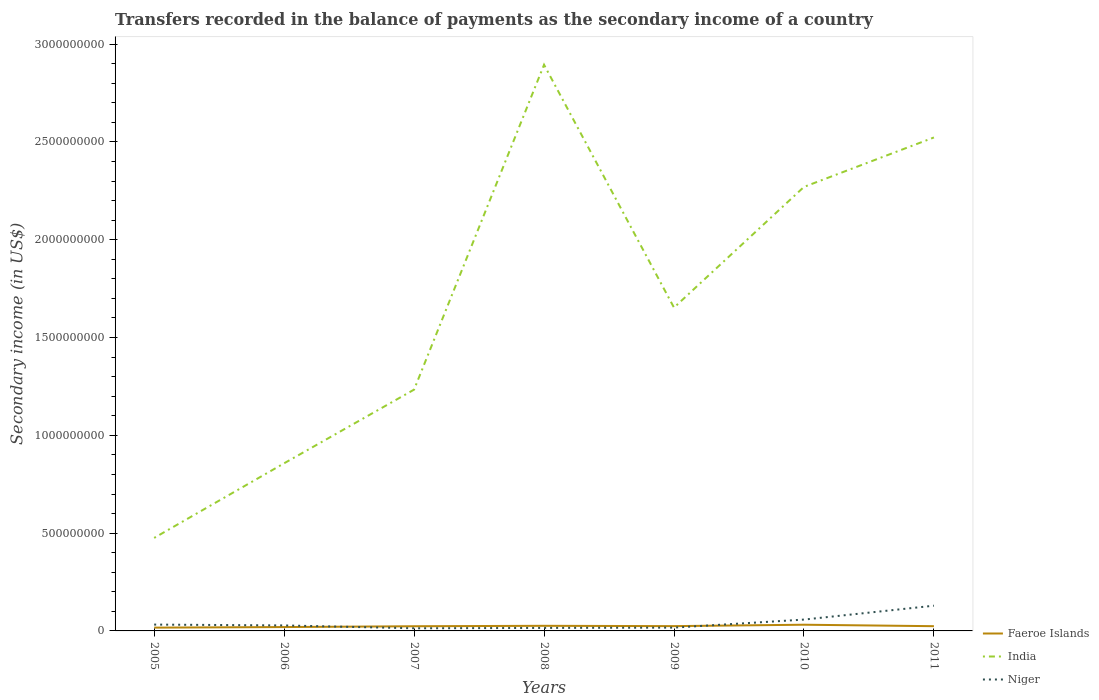Does the line corresponding to India intersect with the line corresponding to Niger?
Give a very brief answer. No. Across all years, what is the maximum secondary income of in Niger?
Keep it short and to the point. 1.35e+07. In which year was the secondary income of in India maximum?
Make the answer very short. 2005. What is the total secondary income of in Faeroe Islands in the graph?
Keep it short and to the point. -4.24e+06. What is the difference between the highest and the second highest secondary income of in Niger?
Make the answer very short. 1.16e+08. Is the secondary income of in Niger strictly greater than the secondary income of in Faeroe Islands over the years?
Offer a terse response. No. How many lines are there?
Provide a short and direct response. 3. Does the graph contain any zero values?
Ensure brevity in your answer.  No. Where does the legend appear in the graph?
Offer a terse response. Bottom right. How many legend labels are there?
Provide a short and direct response. 3. What is the title of the graph?
Offer a terse response. Transfers recorded in the balance of payments as the secondary income of a country. Does "Gabon" appear as one of the legend labels in the graph?
Keep it short and to the point. No. What is the label or title of the X-axis?
Ensure brevity in your answer.  Years. What is the label or title of the Y-axis?
Provide a short and direct response. Secondary income (in US$). What is the Secondary income (in US$) of Faeroe Islands in 2005?
Make the answer very short. 1.69e+07. What is the Secondary income (in US$) in India in 2005?
Your response must be concise. 4.76e+08. What is the Secondary income (in US$) of Niger in 2005?
Offer a very short reply. 3.24e+07. What is the Secondary income (in US$) in Faeroe Islands in 2006?
Make the answer very short. 1.97e+07. What is the Secondary income (in US$) of India in 2006?
Your answer should be very brief. 8.57e+08. What is the Secondary income (in US$) in Niger in 2006?
Offer a terse response. 2.80e+07. What is the Secondary income (in US$) in Faeroe Islands in 2007?
Provide a succinct answer. 2.40e+07. What is the Secondary income (in US$) of India in 2007?
Make the answer very short. 1.23e+09. What is the Secondary income (in US$) of Niger in 2007?
Provide a short and direct response. 1.35e+07. What is the Secondary income (in US$) of Faeroe Islands in 2008?
Make the answer very short. 2.61e+07. What is the Secondary income (in US$) of India in 2008?
Your answer should be very brief. 2.89e+09. What is the Secondary income (in US$) in Niger in 2008?
Your response must be concise. 1.53e+07. What is the Secondary income (in US$) in Faeroe Islands in 2009?
Provide a succinct answer. 2.45e+07. What is the Secondary income (in US$) of India in 2009?
Offer a very short reply. 1.65e+09. What is the Secondary income (in US$) in Niger in 2009?
Ensure brevity in your answer.  1.69e+07. What is the Secondary income (in US$) of Faeroe Islands in 2010?
Keep it short and to the point. 3.17e+07. What is the Secondary income (in US$) in India in 2010?
Offer a terse response. 2.27e+09. What is the Secondary income (in US$) in Niger in 2010?
Provide a succinct answer. 5.80e+07. What is the Secondary income (in US$) of Faeroe Islands in 2011?
Make the answer very short. 2.42e+07. What is the Secondary income (in US$) of India in 2011?
Keep it short and to the point. 2.52e+09. What is the Secondary income (in US$) of Niger in 2011?
Provide a short and direct response. 1.29e+08. Across all years, what is the maximum Secondary income (in US$) in Faeroe Islands?
Your answer should be very brief. 3.17e+07. Across all years, what is the maximum Secondary income (in US$) of India?
Ensure brevity in your answer.  2.89e+09. Across all years, what is the maximum Secondary income (in US$) in Niger?
Your response must be concise. 1.29e+08. Across all years, what is the minimum Secondary income (in US$) of Faeroe Islands?
Give a very brief answer. 1.69e+07. Across all years, what is the minimum Secondary income (in US$) of India?
Provide a succinct answer. 4.76e+08. Across all years, what is the minimum Secondary income (in US$) of Niger?
Give a very brief answer. 1.35e+07. What is the total Secondary income (in US$) in Faeroe Islands in the graph?
Your answer should be compact. 1.67e+08. What is the total Secondary income (in US$) in India in the graph?
Give a very brief answer. 1.19e+1. What is the total Secondary income (in US$) of Niger in the graph?
Your response must be concise. 2.93e+08. What is the difference between the Secondary income (in US$) in Faeroe Islands in 2005 and that in 2006?
Provide a short and direct response. -2.86e+06. What is the difference between the Secondary income (in US$) in India in 2005 and that in 2006?
Ensure brevity in your answer.  -3.82e+08. What is the difference between the Secondary income (in US$) in Niger in 2005 and that in 2006?
Provide a succinct answer. 4.39e+06. What is the difference between the Secondary income (in US$) of Faeroe Islands in 2005 and that in 2007?
Your response must be concise. -7.10e+06. What is the difference between the Secondary income (in US$) of India in 2005 and that in 2007?
Keep it short and to the point. -7.58e+08. What is the difference between the Secondary income (in US$) of Niger in 2005 and that in 2007?
Provide a succinct answer. 1.89e+07. What is the difference between the Secondary income (in US$) in Faeroe Islands in 2005 and that in 2008?
Your response must be concise. -9.24e+06. What is the difference between the Secondary income (in US$) of India in 2005 and that in 2008?
Make the answer very short. -2.42e+09. What is the difference between the Secondary income (in US$) in Niger in 2005 and that in 2008?
Give a very brief answer. 1.71e+07. What is the difference between the Secondary income (in US$) in Faeroe Islands in 2005 and that in 2009?
Make the answer very short. -7.68e+06. What is the difference between the Secondary income (in US$) of India in 2005 and that in 2009?
Your answer should be very brief. -1.18e+09. What is the difference between the Secondary income (in US$) in Niger in 2005 and that in 2009?
Give a very brief answer. 1.56e+07. What is the difference between the Secondary income (in US$) of Faeroe Islands in 2005 and that in 2010?
Provide a succinct answer. -1.49e+07. What is the difference between the Secondary income (in US$) of India in 2005 and that in 2010?
Ensure brevity in your answer.  -1.79e+09. What is the difference between the Secondary income (in US$) in Niger in 2005 and that in 2010?
Offer a terse response. -2.56e+07. What is the difference between the Secondary income (in US$) of Faeroe Islands in 2005 and that in 2011?
Provide a succinct answer. -7.34e+06. What is the difference between the Secondary income (in US$) of India in 2005 and that in 2011?
Provide a succinct answer. -2.05e+09. What is the difference between the Secondary income (in US$) of Niger in 2005 and that in 2011?
Provide a succinct answer. -9.66e+07. What is the difference between the Secondary income (in US$) of Faeroe Islands in 2006 and that in 2007?
Give a very brief answer. -4.24e+06. What is the difference between the Secondary income (in US$) in India in 2006 and that in 2007?
Provide a succinct answer. -3.77e+08. What is the difference between the Secondary income (in US$) of Niger in 2006 and that in 2007?
Make the answer very short. 1.46e+07. What is the difference between the Secondary income (in US$) of Faeroe Islands in 2006 and that in 2008?
Your response must be concise. -6.37e+06. What is the difference between the Secondary income (in US$) in India in 2006 and that in 2008?
Ensure brevity in your answer.  -2.04e+09. What is the difference between the Secondary income (in US$) of Niger in 2006 and that in 2008?
Provide a succinct answer. 1.27e+07. What is the difference between the Secondary income (in US$) in Faeroe Islands in 2006 and that in 2009?
Provide a succinct answer. -4.82e+06. What is the difference between the Secondary income (in US$) in India in 2006 and that in 2009?
Your answer should be compact. -7.96e+08. What is the difference between the Secondary income (in US$) in Niger in 2006 and that in 2009?
Provide a short and direct response. 1.12e+07. What is the difference between the Secondary income (in US$) in Faeroe Islands in 2006 and that in 2010?
Your answer should be compact. -1.20e+07. What is the difference between the Secondary income (in US$) of India in 2006 and that in 2010?
Your response must be concise. -1.41e+09. What is the difference between the Secondary income (in US$) of Niger in 2006 and that in 2010?
Ensure brevity in your answer.  -3.00e+07. What is the difference between the Secondary income (in US$) in Faeroe Islands in 2006 and that in 2011?
Offer a very short reply. -4.48e+06. What is the difference between the Secondary income (in US$) in India in 2006 and that in 2011?
Make the answer very short. -1.67e+09. What is the difference between the Secondary income (in US$) of Niger in 2006 and that in 2011?
Ensure brevity in your answer.  -1.01e+08. What is the difference between the Secondary income (in US$) of Faeroe Islands in 2007 and that in 2008?
Offer a very short reply. -2.14e+06. What is the difference between the Secondary income (in US$) of India in 2007 and that in 2008?
Make the answer very short. -1.66e+09. What is the difference between the Secondary income (in US$) of Niger in 2007 and that in 2008?
Provide a succinct answer. -1.83e+06. What is the difference between the Secondary income (in US$) of Faeroe Islands in 2007 and that in 2009?
Make the answer very short. -5.79e+05. What is the difference between the Secondary income (in US$) of India in 2007 and that in 2009?
Make the answer very short. -4.19e+08. What is the difference between the Secondary income (in US$) of Niger in 2007 and that in 2009?
Keep it short and to the point. -3.37e+06. What is the difference between the Secondary income (in US$) of Faeroe Islands in 2007 and that in 2010?
Your response must be concise. -7.79e+06. What is the difference between the Secondary income (in US$) of India in 2007 and that in 2010?
Your answer should be very brief. -1.04e+09. What is the difference between the Secondary income (in US$) in Niger in 2007 and that in 2010?
Your response must be concise. -4.45e+07. What is the difference between the Secondary income (in US$) of Faeroe Islands in 2007 and that in 2011?
Ensure brevity in your answer.  -2.42e+05. What is the difference between the Secondary income (in US$) of India in 2007 and that in 2011?
Give a very brief answer. -1.29e+09. What is the difference between the Secondary income (in US$) in Niger in 2007 and that in 2011?
Keep it short and to the point. -1.16e+08. What is the difference between the Secondary income (in US$) in Faeroe Islands in 2008 and that in 2009?
Your answer should be compact. 1.56e+06. What is the difference between the Secondary income (in US$) of India in 2008 and that in 2009?
Provide a succinct answer. 1.24e+09. What is the difference between the Secondary income (in US$) in Niger in 2008 and that in 2009?
Provide a succinct answer. -1.55e+06. What is the difference between the Secondary income (in US$) of Faeroe Islands in 2008 and that in 2010?
Your answer should be very brief. -5.65e+06. What is the difference between the Secondary income (in US$) in India in 2008 and that in 2010?
Provide a succinct answer. 6.25e+08. What is the difference between the Secondary income (in US$) of Niger in 2008 and that in 2010?
Provide a succinct answer. -4.27e+07. What is the difference between the Secondary income (in US$) of Faeroe Islands in 2008 and that in 2011?
Your response must be concise. 1.90e+06. What is the difference between the Secondary income (in US$) of India in 2008 and that in 2011?
Provide a short and direct response. 3.72e+08. What is the difference between the Secondary income (in US$) in Niger in 2008 and that in 2011?
Provide a short and direct response. -1.14e+08. What is the difference between the Secondary income (in US$) of Faeroe Islands in 2009 and that in 2010?
Offer a terse response. -7.21e+06. What is the difference between the Secondary income (in US$) of India in 2009 and that in 2010?
Offer a terse response. -6.17e+08. What is the difference between the Secondary income (in US$) of Niger in 2009 and that in 2010?
Provide a short and direct response. -4.12e+07. What is the difference between the Secondary income (in US$) in Faeroe Islands in 2009 and that in 2011?
Give a very brief answer. 3.37e+05. What is the difference between the Secondary income (in US$) in India in 2009 and that in 2011?
Provide a short and direct response. -8.70e+08. What is the difference between the Secondary income (in US$) in Niger in 2009 and that in 2011?
Your answer should be compact. -1.12e+08. What is the difference between the Secondary income (in US$) in Faeroe Islands in 2010 and that in 2011?
Offer a very short reply. 7.55e+06. What is the difference between the Secondary income (in US$) of India in 2010 and that in 2011?
Your answer should be compact. -2.53e+08. What is the difference between the Secondary income (in US$) in Niger in 2010 and that in 2011?
Your response must be concise. -7.10e+07. What is the difference between the Secondary income (in US$) in Faeroe Islands in 2005 and the Secondary income (in US$) in India in 2006?
Make the answer very short. -8.40e+08. What is the difference between the Secondary income (in US$) in Faeroe Islands in 2005 and the Secondary income (in US$) in Niger in 2006?
Provide a short and direct response. -1.12e+07. What is the difference between the Secondary income (in US$) of India in 2005 and the Secondary income (in US$) of Niger in 2006?
Your answer should be very brief. 4.47e+08. What is the difference between the Secondary income (in US$) of Faeroe Islands in 2005 and the Secondary income (in US$) of India in 2007?
Keep it short and to the point. -1.22e+09. What is the difference between the Secondary income (in US$) of Faeroe Islands in 2005 and the Secondary income (in US$) of Niger in 2007?
Offer a terse response. 3.38e+06. What is the difference between the Secondary income (in US$) of India in 2005 and the Secondary income (in US$) of Niger in 2007?
Your response must be concise. 4.62e+08. What is the difference between the Secondary income (in US$) in Faeroe Islands in 2005 and the Secondary income (in US$) in India in 2008?
Offer a terse response. -2.88e+09. What is the difference between the Secondary income (in US$) of Faeroe Islands in 2005 and the Secondary income (in US$) of Niger in 2008?
Your answer should be very brief. 1.55e+06. What is the difference between the Secondary income (in US$) in India in 2005 and the Secondary income (in US$) in Niger in 2008?
Give a very brief answer. 4.60e+08. What is the difference between the Secondary income (in US$) in Faeroe Islands in 2005 and the Secondary income (in US$) in India in 2009?
Offer a very short reply. -1.64e+09. What is the difference between the Secondary income (in US$) of Faeroe Islands in 2005 and the Secondary income (in US$) of Niger in 2009?
Offer a very short reply. 5214.1. What is the difference between the Secondary income (in US$) in India in 2005 and the Secondary income (in US$) in Niger in 2009?
Your answer should be compact. 4.59e+08. What is the difference between the Secondary income (in US$) in Faeroe Islands in 2005 and the Secondary income (in US$) in India in 2010?
Your answer should be compact. -2.25e+09. What is the difference between the Secondary income (in US$) in Faeroe Islands in 2005 and the Secondary income (in US$) in Niger in 2010?
Keep it short and to the point. -4.11e+07. What is the difference between the Secondary income (in US$) in India in 2005 and the Secondary income (in US$) in Niger in 2010?
Provide a succinct answer. 4.18e+08. What is the difference between the Secondary income (in US$) of Faeroe Islands in 2005 and the Secondary income (in US$) of India in 2011?
Ensure brevity in your answer.  -2.51e+09. What is the difference between the Secondary income (in US$) in Faeroe Islands in 2005 and the Secondary income (in US$) in Niger in 2011?
Provide a short and direct response. -1.12e+08. What is the difference between the Secondary income (in US$) of India in 2005 and the Secondary income (in US$) of Niger in 2011?
Offer a terse response. 3.47e+08. What is the difference between the Secondary income (in US$) in Faeroe Islands in 2006 and the Secondary income (in US$) in India in 2007?
Make the answer very short. -1.21e+09. What is the difference between the Secondary income (in US$) of Faeroe Islands in 2006 and the Secondary income (in US$) of Niger in 2007?
Offer a terse response. 6.24e+06. What is the difference between the Secondary income (in US$) in India in 2006 and the Secondary income (in US$) in Niger in 2007?
Offer a very short reply. 8.44e+08. What is the difference between the Secondary income (in US$) of Faeroe Islands in 2006 and the Secondary income (in US$) of India in 2008?
Your response must be concise. -2.87e+09. What is the difference between the Secondary income (in US$) of Faeroe Islands in 2006 and the Secondary income (in US$) of Niger in 2008?
Your answer should be compact. 4.41e+06. What is the difference between the Secondary income (in US$) of India in 2006 and the Secondary income (in US$) of Niger in 2008?
Your answer should be very brief. 8.42e+08. What is the difference between the Secondary income (in US$) of Faeroe Islands in 2006 and the Secondary income (in US$) of India in 2009?
Offer a very short reply. -1.63e+09. What is the difference between the Secondary income (in US$) of Faeroe Islands in 2006 and the Secondary income (in US$) of Niger in 2009?
Offer a terse response. 2.87e+06. What is the difference between the Secondary income (in US$) of India in 2006 and the Secondary income (in US$) of Niger in 2009?
Provide a succinct answer. 8.40e+08. What is the difference between the Secondary income (in US$) of Faeroe Islands in 2006 and the Secondary income (in US$) of India in 2010?
Your answer should be compact. -2.25e+09. What is the difference between the Secondary income (in US$) of Faeroe Islands in 2006 and the Secondary income (in US$) of Niger in 2010?
Ensure brevity in your answer.  -3.83e+07. What is the difference between the Secondary income (in US$) of India in 2006 and the Secondary income (in US$) of Niger in 2010?
Provide a short and direct response. 7.99e+08. What is the difference between the Secondary income (in US$) of Faeroe Islands in 2006 and the Secondary income (in US$) of India in 2011?
Offer a terse response. -2.50e+09. What is the difference between the Secondary income (in US$) of Faeroe Islands in 2006 and the Secondary income (in US$) of Niger in 2011?
Provide a short and direct response. -1.09e+08. What is the difference between the Secondary income (in US$) in India in 2006 and the Secondary income (in US$) in Niger in 2011?
Provide a succinct answer. 7.28e+08. What is the difference between the Secondary income (in US$) in Faeroe Islands in 2007 and the Secondary income (in US$) in India in 2008?
Your answer should be very brief. -2.87e+09. What is the difference between the Secondary income (in US$) in Faeroe Islands in 2007 and the Secondary income (in US$) in Niger in 2008?
Provide a short and direct response. 8.65e+06. What is the difference between the Secondary income (in US$) in India in 2007 and the Secondary income (in US$) in Niger in 2008?
Provide a short and direct response. 1.22e+09. What is the difference between the Secondary income (in US$) in Faeroe Islands in 2007 and the Secondary income (in US$) in India in 2009?
Give a very brief answer. -1.63e+09. What is the difference between the Secondary income (in US$) in Faeroe Islands in 2007 and the Secondary income (in US$) in Niger in 2009?
Offer a terse response. 7.10e+06. What is the difference between the Secondary income (in US$) of India in 2007 and the Secondary income (in US$) of Niger in 2009?
Provide a short and direct response. 1.22e+09. What is the difference between the Secondary income (in US$) in Faeroe Islands in 2007 and the Secondary income (in US$) in India in 2010?
Offer a terse response. -2.25e+09. What is the difference between the Secondary income (in US$) of Faeroe Islands in 2007 and the Secondary income (in US$) of Niger in 2010?
Offer a terse response. -3.40e+07. What is the difference between the Secondary income (in US$) in India in 2007 and the Secondary income (in US$) in Niger in 2010?
Give a very brief answer. 1.18e+09. What is the difference between the Secondary income (in US$) of Faeroe Islands in 2007 and the Secondary income (in US$) of India in 2011?
Provide a succinct answer. -2.50e+09. What is the difference between the Secondary income (in US$) of Faeroe Islands in 2007 and the Secondary income (in US$) of Niger in 2011?
Give a very brief answer. -1.05e+08. What is the difference between the Secondary income (in US$) in India in 2007 and the Secondary income (in US$) in Niger in 2011?
Your response must be concise. 1.10e+09. What is the difference between the Secondary income (in US$) in Faeroe Islands in 2008 and the Secondary income (in US$) in India in 2009?
Keep it short and to the point. -1.63e+09. What is the difference between the Secondary income (in US$) in Faeroe Islands in 2008 and the Secondary income (in US$) in Niger in 2009?
Provide a short and direct response. 9.24e+06. What is the difference between the Secondary income (in US$) in India in 2008 and the Secondary income (in US$) in Niger in 2009?
Offer a terse response. 2.88e+09. What is the difference between the Secondary income (in US$) in Faeroe Islands in 2008 and the Secondary income (in US$) in India in 2010?
Offer a very short reply. -2.24e+09. What is the difference between the Secondary income (in US$) of Faeroe Islands in 2008 and the Secondary income (in US$) of Niger in 2010?
Make the answer very short. -3.19e+07. What is the difference between the Secondary income (in US$) in India in 2008 and the Secondary income (in US$) in Niger in 2010?
Provide a short and direct response. 2.84e+09. What is the difference between the Secondary income (in US$) in Faeroe Islands in 2008 and the Secondary income (in US$) in India in 2011?
Offer a terse response. -2.50e+09. What is the difference between the Secondary income (in US$) of Faeroe Islands in 2008 and the Secondary income (in US$) of Niger in 2011?
Make the answer very short. -1.03e+08. What is the difference between the Secondary income (in US$) of India in 2008 and the Secondary income (in US$) of Niger in 2011?
Make the answer very short. 2.77e+09. What is the difference between the Secondary income (in US$) of Faeroe Islands in 2009 and the Secondary income (in US$) of India in 2010?
Keep it short and to the point. -2.25e+09. What is the difference between the Secondary income (in US$) of Faeroe Islands in 2009 and the Secondary income (in US$) of Niger in 2010?
Provide a succinct answer. -3.35e+07. What is the difference between the Secondary income (in US$) of India in 2009 and the Secondary income (in US$) of Niger in 2010?
Your response must be concise. 1.59e+09. What is the difference between the Secondary income (in US$) in Faeroe Islands in 2009 and the Secondary income (in US$) in India in 2011?
Keep it short and to the point. -2.50e+09. What is the difference between the Secondary income (in US$) of Faeroe Islands in 2009 and the Secondary income (in US$) of Niger in 2011?
Your response must be concise. -1.04e+08. What is the difference between the Secondary income (in US$) in India in 2009 and the Secondary income (in US$) in Niger in 2011?
Provide a short and direct response. 1.52e+09. What is the difference between the Secondary income (in US$) in Faeroe Islands in 2010 and the Secondary income (in US$) in India in 2011?
Your answer should be compact. -2.49e+09. What is the difference between the Secondary income (in US$) of Faeroe Islands in 2010 and the Secondary income (in US$) of Niger in 2011?
Offer a very short reply. -9.72e+07. What is the difference between the Secondary income (in US$) in India in 2010 and the Secondary income (in US$) in Niger in 2011?
Keep it short and to the point. 2.14e+09. What is the average Secondary income (in US$) of Faeroe Islands per year?
Your response must be concise. 2.39e+07. What is the average Secondary income (in US$) in India per year?
Provide a short and direct response. 1.70e+09. What is the average Secondary income (in US$) of Niger per year?
Give a very brief answer. 4.19e+07. In the year 2005, what is the difference between the Secondary income (in US$) of Faeroe Islands and Secondary income (in US$) of India?
Offer a terse response. -4.59e+08. In the year 2005, what is the difference between the Secondary income (in US$) in Faeroe Islands and Secondary income (in US$) in Niger?
Make the answer very short. -1.56e+07. In the year 2005, what is the difference between the Secondary income (in US$) of India and Secondary income (in US$) of Niger?
Offer a terse response. 4.43e+08. In the year 2006, what is the difference between the Secondary income (in US$) in Faeroe Islands and Secondary income (in US$) in India?
Offer a very short reply. -8.37e+08. In the year 2006, what is the difference between the Secondary income (in US$) in Faeroe Islands and Secondary income (in US$) in Niger?
Offer a terse response. -8.31e+06. In the year 2006, what is the difference between the Secondary income (in US$) of India and Secondary income (in US$) of Niger?
Offer a very short reply. 8.29e+08. In the year 2007, what is the difference between the Secondary income (in US$) of Faeroe Islands and Secondary income (in US$) of India?
Give a very brief answer. -1.21e+09. In the year 2007, what is the difference between the Secondary income (in US$) in Faeroe Islands and Secondary income (in US$) in Niger?
Provide a succinct answer. 1.05e+07. In the year 2007, what is the difference between the Secondary income (in US$) in India and Secondary income (in US$) in Niger?
Offer a very short reply. 1.22e+09. In the year 2008, what is the difference between the Secondary income (in US$) in Faeroe Islands and Secondary income (in US$) in India?
Keep it short and to the point. -2.87e+09. In the year 2008, what is the difference between the Secondary income (in US$) of Faeroe Islands and Secondary income (in US$) of Niger?
Offer a terse response. 1.08e+07. In the year 2008, what is the difference between the Secondary income (in US$) in India and Secondary income (in US$) in Niger?
Your answer should be very brief. 2.88e+09. In the year 2009, what is the difference between the Secondary income (in US$) in Faeroe Islands and Secondary income (in US$) in India?
Keep it short and to the point. -1.63e+09. In the year 2009, what is the difference between the Secondary income (in US$) of Faeroe Islands and Secondary income (in US$) of Niger?
Your answer should be compact. 7.68e+06. In the year 2009, what is the difference between the Secondary income (in US$) in India and Secondary income (in US$) in Niger?
Offer a very short reply. 1.64e+09. In the year 2010, what is the difference between the Secondary income (in US$) in Faeroe Islands and Secondary income (in US$) in India?
Provide a short and direct response. -2.24e+09. In the year 2010, what is the difference between the Secondary income (in US$) in Faeroe Islands and Secondary income (in US$) in Niger?
Your answer should be very brief. -2.63e+07. In the year 2010, what is the difference between the Secondary income (in US$) of India and Secondary income (in US$) of Niger?
Provide a short and direct response. 2.21e+09. In the year 2011, what is the difference between the Secondary income (in US$) in Faeroe Islands and Secondary income (in US$) in India?
Provide a short and direct response. -2.50e+09. In the year 2011, what is the difference between the Secondary income (in US$) of Faeroe Islands and Secondary income (in US$) of Niger?
Provide a short and direct response. -1.05e+08. In the year 2011, what is the difference between the Secondary income (in US$) of India and Secondary income (in US$) of Niger?
Your answer should be very brief. 2.39e+09. What is the ratio of the Secondary income (in US$) in Faeroe Islands in 2005 to that in 2006?
Your answer should be compact. 0.85. What is the ratio of the Secondary income (in US$) of India in 2005 to that in 2006?
Offer a terse response. 0.55. What is the ratio of the Secondary income (in US$) of Niger in 2005 to that in 2006?
Offer a terse response. 1.16. What is the ratio of the Secondary income (in US$) in Faeroe Islands in 2005 to that in 2007?
Your answer should be very brief. 0.7. What is the ratio of the Secondary income (in US$) of India in 2005 to that in 2007?
Provide a short and direct response. 0.39. What is the ratio of the Secondary income (in US$) in Niger in 2005 to that in 2007?
Your answer should be very brief. 2.41. What is the ratio of the Secondary income (in US$) in Faeroe Islands in 2005 to that in 2008?
Offer a very short reply. 0.65. What is the ratio of the Secondary income (in US$) in India in 2005 to that in 2008?
Your answer should be compact. 0.16. What is the ratio of the Secondary income (in US$) of Niger in 2005 to that in 2008?
Keep it short and to the point. 2.12. What is the ratio of the Secondary income (in US$) of Faeroe Islands in 2005 to that in 2009?
Provide a short and direct response. 0.69. What is the ratio of the Secondary income (in US$) of India in 2005 to that in 2009?
Provide a succinct answer. 0.29. What is the ratio of the Secondary income (in US$) in Niger in 2005 to that in 2009?
Offer a very short reply. 1.92. What is the ratio of the Secondary income (in US$) of Faeroe Islands in 2005 to that in 2010?
Your answer should be very brief. 0.53. What is the ratio of the Secondary income (in US$) in India in 2005 to that in 2010?
Make the answer very short. 0.21. What is the ratio of the Secondary income (in US$) of Niger in 2005 to that in 2010?
Your answer should be very brief. 0.56. What is the ratio of the Secondary income (in US$) in Faeroe Islands in 2005 to that in 2011?
Your answer should be compact. 0.7. What is the ratio of the Secondary income (in US$) in India in 2005 to that in 2011?
Your answer should be very brief. 0.19. What is the ratio of the Secondary income (in US$) of Niger in 2005 to that in 2011?
Offer a very short reply. 0.25. What is the ratio of the Secondary income (in US$) of Faeroe Islands in 2006 to that in 2007?
Your response must be concise. 0.82. What is the ratio of the Secondary income (in US$) in India in 2006 to that in 2007?
Give a very brief answer. 0.69. What is the ratio of the Secondary income (in US$) in Niger in 2006 to that in 2007?
Your answer should be very brief. 2.08. What is the ratio of the Secondary income (in US$) in Faeroe Islands in 2006 to that in 2008?
Ensure brevity in your answer.  0.76. What is the ratio of the Secondary income (in US$) of India in 2006 to that in 2008?
Provide a short and direct response. 0.3. What is the ratio of the Secondary income (in US$) of Niger in 2006 to that in 2008?
Your answer should be very brief. 1.83. What is the ratio of the Secondary income (in US$) in Faeroe Islands in 2006 to that in 2009?
Make the answer very short. 0.8. What is the ratio of the Secondary income (in US$) of India in 2006 to that in 2009?
Offer a terse response. 0.52. What is the ratio of the Secondary income (in US$) of Niger in 2006 to that in 2009?
Ensure brevity in your answer.  1.66. What is the ratio of the Secondary income (in US$) of Faeroe Islands in 2006 to that in 2010?
Your answer should be compact. 0.62. What is the ratio of the Secondary income (in US$) of India in 2006 to that in 2010?
Offer a very short reply. 0.38. What is the ratio of the Secondary income (in US$) of Niger in 2006 to that in 2010?
Provide a short and direct response. 0.48. What is the ratio of the Secondary income (in US$) in Faeroe Islands in 2006 to that in 2011?
Provide a short and direct response. 0.81. What is the ratio of the Secondary income (in US$) in India in 2006 to that in 2011?
Give a very brief answer. 0.34. What is the ratio of the Secondary income (in US$) of Niger in 2006 to that in 2011?
Keep it short and to the point. 0.22. What is the ratio of the Secondary income (in US$) in Faeroe Islands in 2007 to that in 2008?
Make the answer very short. 0.92. What is the ratio of the Secondary income (in US$) in India in 2007 to that in 2008?
Provide a succinct answer. 0.43. What is the ratio of the Secondary income (in US$) in Niger in 2007 to that in 2008?
Provide a succinct answer. 0.88. What is the ratio of the Secondary income (in US$) in Faeroe Islands in 2007 to that in 2009?
Keep it short and to the point. 0.98. What is the ratio of the Secondary income (in US$) of India in 2007 to that in 2009?
Your response must be concise. 0.75. What is the ratio of the Secondary income (in US$) of Niger in 2007 to that in 2009?
Offer a terse response. 0.8. What is the ratio of the Secondary income (in US$) of Faeroe Islands in 2007 to that in 2010?
Give a very brief answer. 0.75. What is the ratio of the Secondary income (in US$) of India in 2007 to that in 2010?
Give a very brief answer. 0.54. What is the ratio of the Secondary income (in US$) in Niger in 2007 to that in 2010?
Offer a terse response. 0.23. What is the ratio of the Secondary income (in US$) in India in 2007 to that in 2011?
Offer a very short reply. 0.49. What is the ratio of the Secondary income (in US$) in Niger in 2007 to that in 2011?
Provide a succinct answer. 0.1. What is the ratio of the Secondary income (in US$) of Faeroe Islands in 2008 to that in 2009?
Your response must be concise. 1.06. What is the ratio of the Secondary income (in US$) of India in 2008 to that in 2009?
Make the answer very short. 1.75. What is the ratio of the Secondary income (in US$) of Niger in 2008 to that in 2009?
Provide a succinct answer. 0.91. What is the ratio of the Secondary income (in US$) in Faeroe Islands in 2008 to that in 2010?
Keep it short and to the point. 0.82. What is the ratio of the Secondary income (in US$) of India in 2008 to that in 2010?
Your answer should be compact. 1.28. What is the ratio of the Secondary income (in US$) of Niger in 2008 to that in 2010?
Offer a very short reply. 0.26. What is the ratio of the Secondary income (in US$) in Faeroe Islands in 2008 to that in 2011?
Provide a succinct answer. 1.08. What is the ratio of the Secondary income (in US$) in India in 2008 to that in 2011?
Give a very brief answer. 1.15. What is the ratio of the Secondary income (in US$) in Niger in 2008 to that in 2011?
Make the answer very short. 0.12. What is the ratio of the Secondary income (in US$) of Faeroe Islands in 2009 to that in 2010?
Make the answer very short. 0.77. What is the ratio of the Secondary income (in US$) of India in 2009 to that in 2010?
Ensure brevity in your answer.  0.73. What is the ratio of the Secondary income (in US$) in Niger in 2009 to that in 2010?
Provide a short and direct response. 0.29. What is the ratio of the Secondary income (in US$) in Faeroe Islands in 2009 to that in 2011?
Ensure brevity in your answer.  1.01. What is the ratio of the Secondary income (in US$) of India in 2009 to that in 2011?
Provide a succinct answer. 0.66. What is the ratio of the Secondary income (in US$) of Niger in 2009 to that in 2011?
Keep it short and to the point. 0.13. What is the ratio of the Secondary income (in US$) of Faeroe Islands in 2010 to that in 2011?
Your response must be concise. 1.31. What is the ratio of the Secondary income (in US$) of India in 2010 to that in 2011?
Your answer should be very brief. 0.9. What is the ratio of the Secondary income (in US$) of Niger in 2010 to that in 2011?
Your answer should be very brief. 0.45. What is the difference between the highest and the second highest Secondary income (in US$) of Faeroe Islands?
Keep it short and to the point. 5.65e+06. What is the difference between the highest and the second highest Secondary income (in US$) in India?
Provide a short and direct response. 3.72e+08. What is the difference between the highest and the second highest Secondary income (in US$) in Niger?
Offer a very short reply. 7.10e+07. What is the difference between the highest and the lowest Secondary income (in US$) in Faeroe Islands?
Make the answer very short. 1.49e+07. What is the difference between the highest and the lowest Secondary income (in US$) of India?
Offer a terse response. 2.42e+09. What is the difference between the highest and the lowest Secondary income (in US$) in Niger?
Make the answer very short. 1.16e+08. 